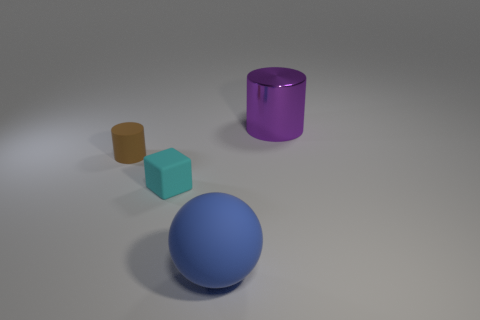Add 1 brown cylinders. How many objects exist? 5 Subtract all brown cylinders. How many cylinders are left? 1 Subtract all balls. How many objects are left? 3 Subtract 1 cubes. How many cubes are left? 0 Subtract all small cyan rubber cubes. Subtract all tiny balls. How many objects are left? 3 Add 2 big blue spheres. How many big blue spheres are left? 3 Add 2 yellow metal balls. How many yellow metal balls exist? 2 Subtract 0 cyan cylinders. How many objects are left? 4 Subtract all red blocks. Subtract all blue cylinders. How many blocks are left? 1 